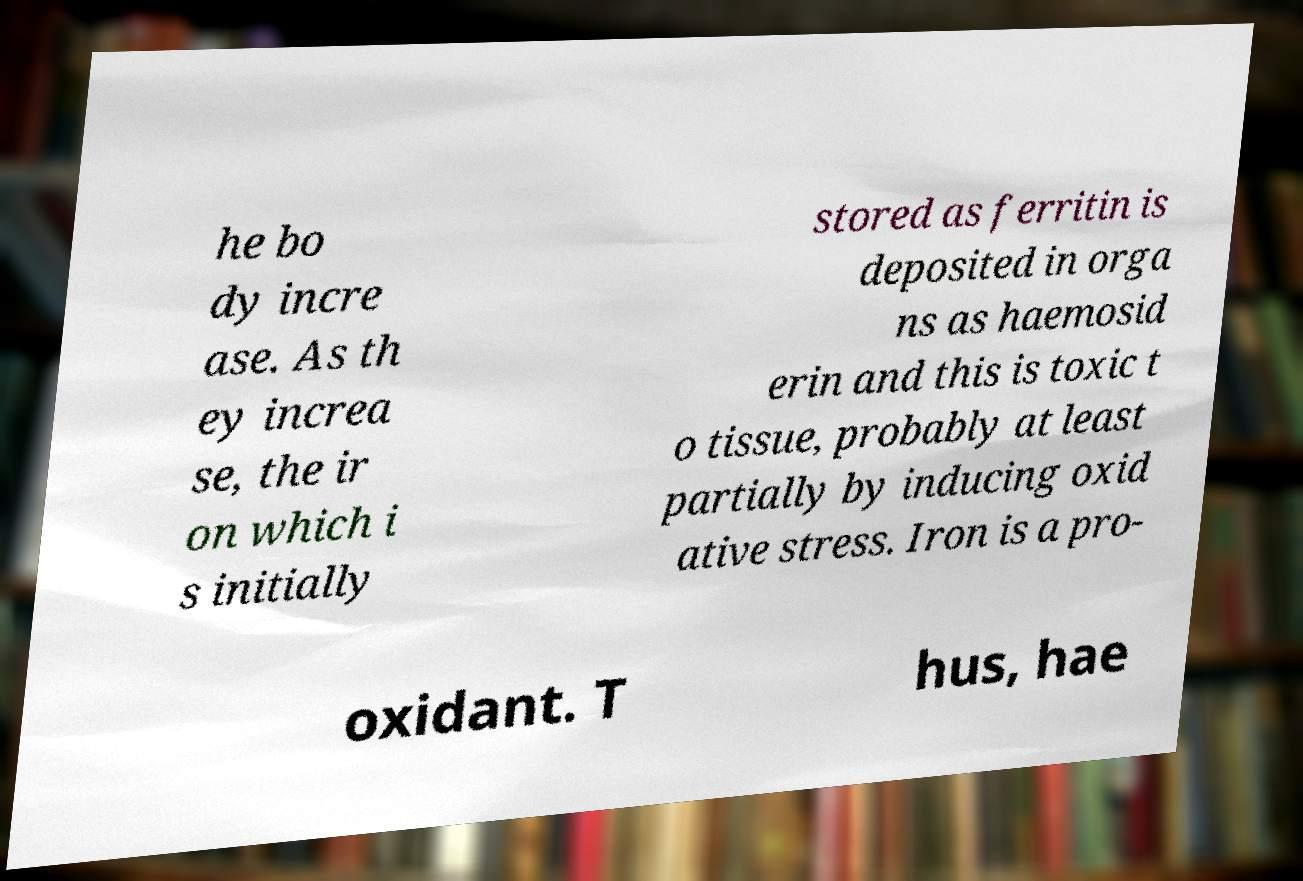Please read and relay the text visible in this image. What does it say? he bo dy incre ase. As th ey increa se, the ir on which i s initially stored as ferritin is deposited in orga ns as haemosid erin and this is toxic t o tissue, probably at least partially by inducing oxid ative stress. Iron is a pro- oxidant. T hus, hae 